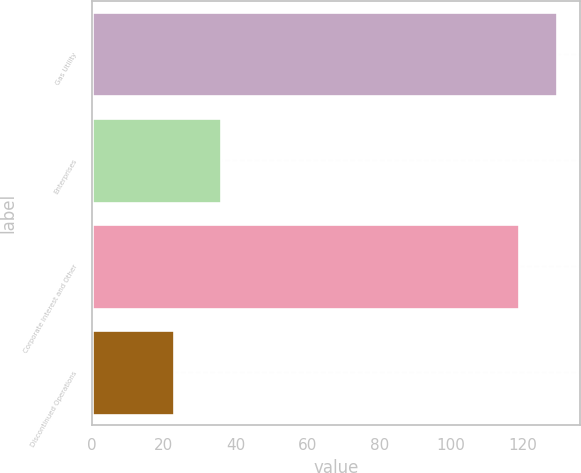Convert chart to OTSL. <chart><loc_0><loc_0><loc_500><loc_500><bar_chart><fcel>Gas Utility<fcel>Enterprises<fcel>Corporate Interest and Other<fcel>Discontinued Operations<nl><fcel>129.4<fcel>36<fcel>119<fcel>23<nl></chart> 